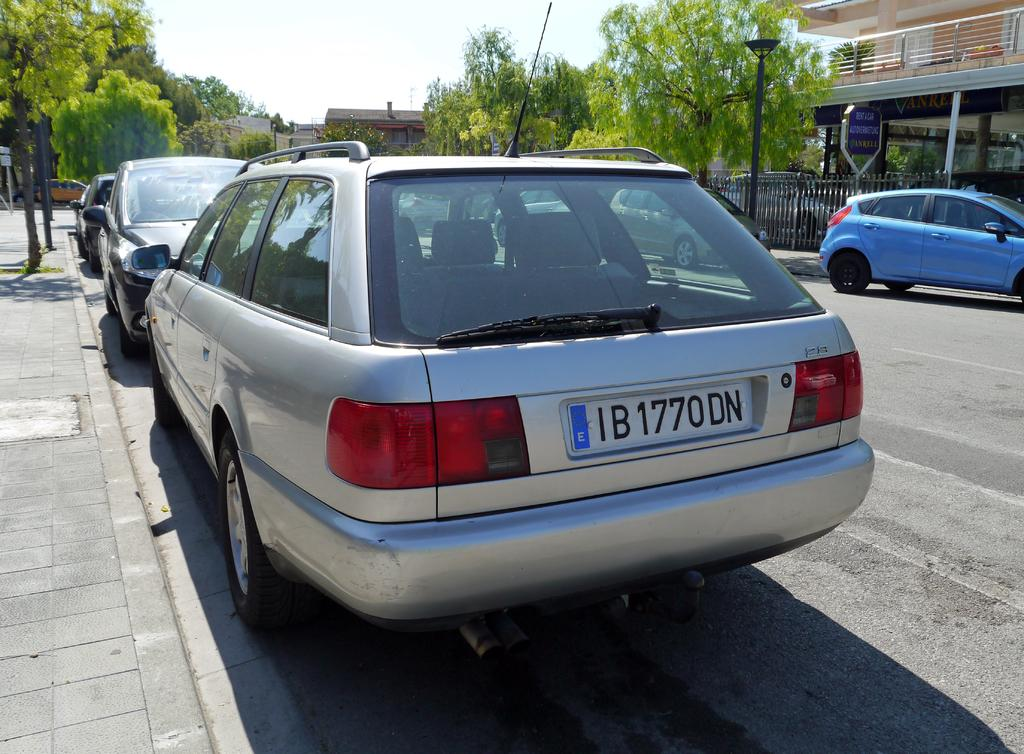<image>
Relay a brief, clear account of the picture shown. a silver car with plate B 1770DN parked on a street 